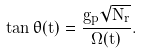<formula> <loc_0><loc_0><loc_500><loc_500>\tan \theta ( t ) = \frac { g _ { p } \sqrt { N _ { r } } } { \Omega ( t ) } .</formula> 